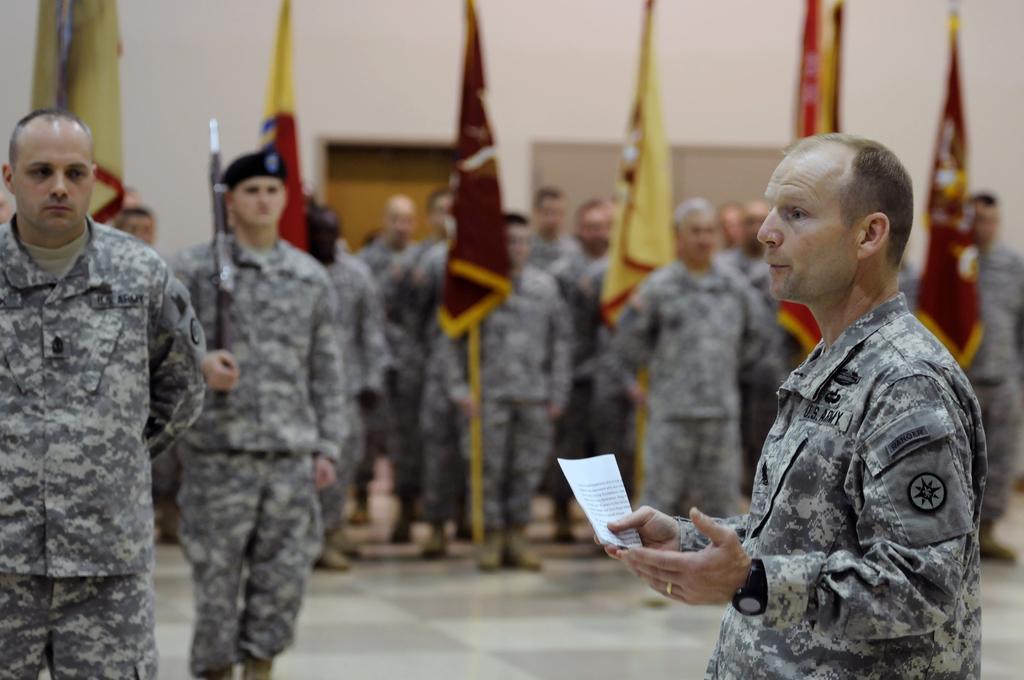In one or two sentences, can you explain what this image depicts? On the right side there is a man wearing uniform, holding a paper in the hand, facing towards the left side and speaking. In the background there are few men wearing uniforms and standing on the floor. There are few flags and also I can see the wall. 